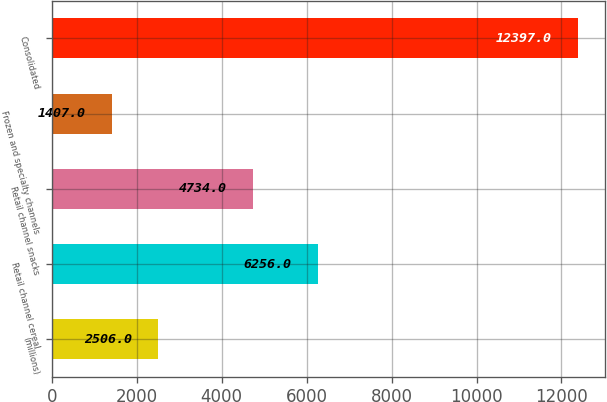Convert chart to OTSL. <chart><loc_0><loc_0><loc_500><loc_500><bar_chart><fcel>(millions)<fcel>Retail channel cereal<fcel>Retail channel snacks<fcel>Frozen and specialty channels<fcel>Consolidated<nl><fcel>2506<fcel>6256<fcel>4734<fcel>1407<fcel>12397<nl></chart> 